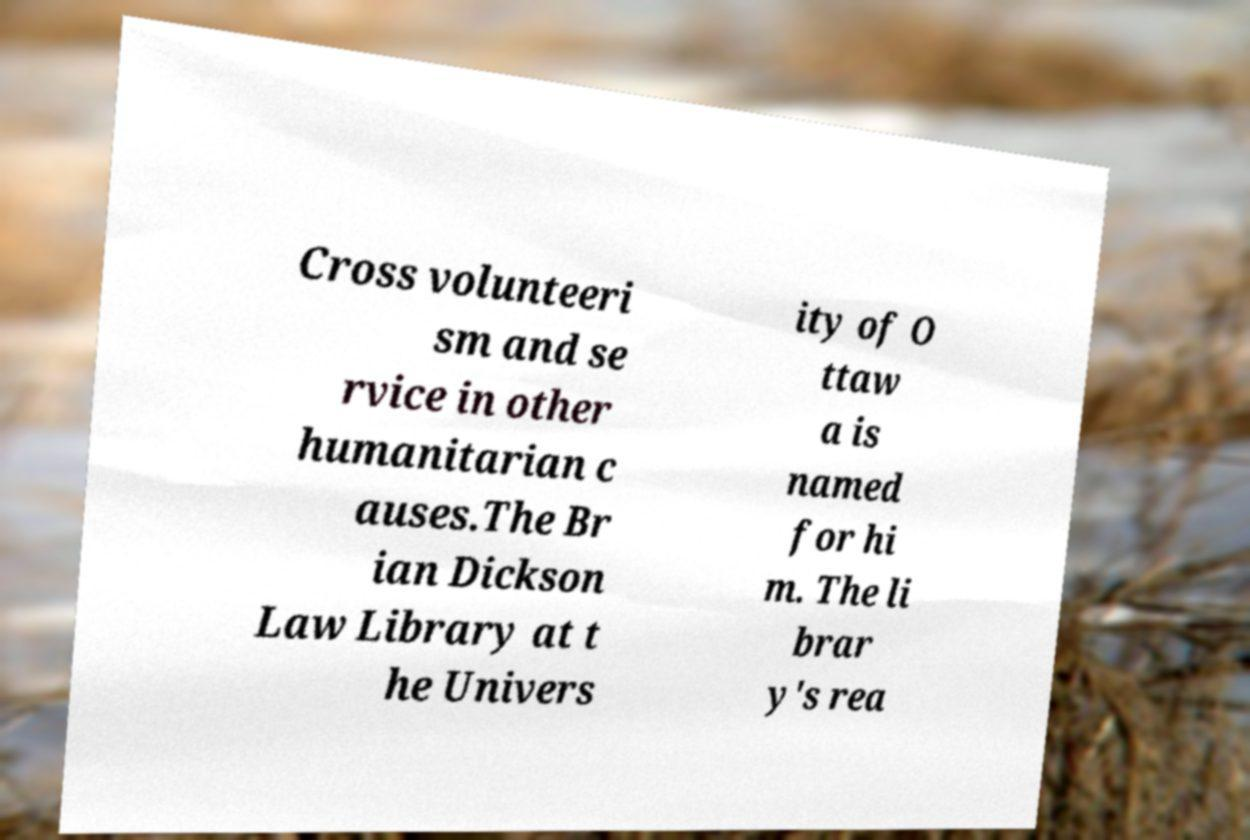Can you accurately transcribe the text from the provided image for me? Cross volunteeri sm and se rvice in other humanitarian c auses.The Br ian Dickson Law Library at t he Univers ity of O ttaw a is named for hi m. The li brar y's rea 